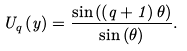Convert formula to latex. <formula><loc_0><loc_0><loc_500><loc_500>U _ { q } \left ( y \right ) = \frac { \sin \left ( { \left ( { q + 1 } \right ) \theta } \right ) } { \sin \left ( \theta \right ) } .</formula> 